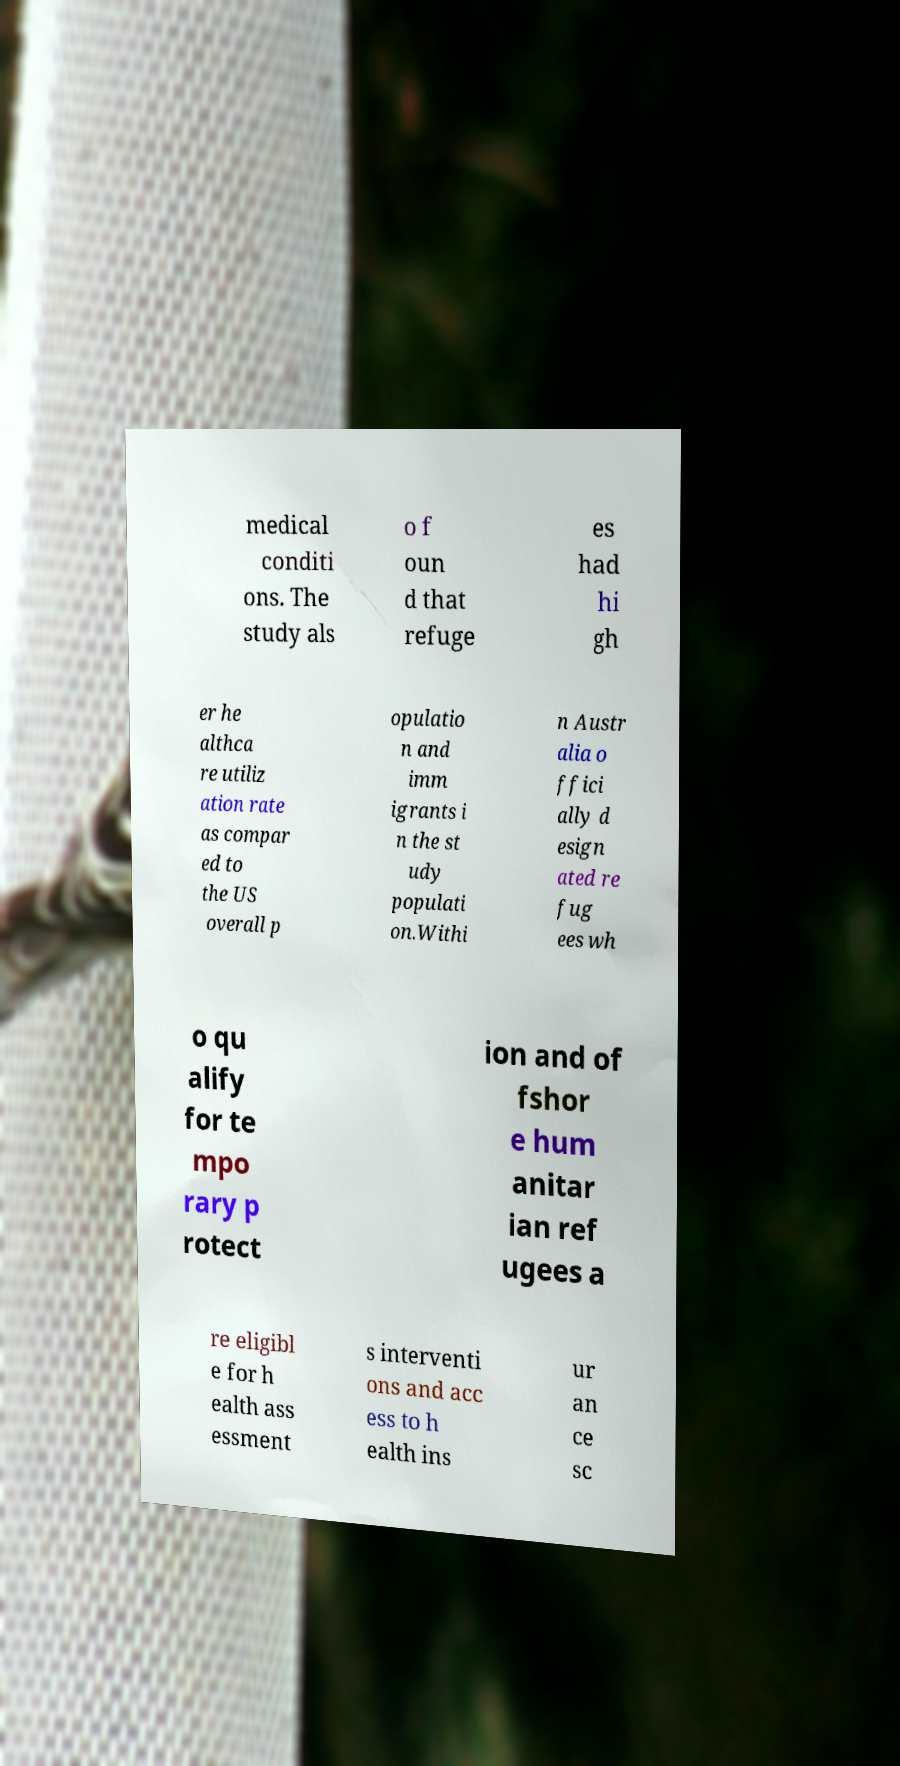Please identify and transcribe the text found in this image. medical conditi ons. The study als o f oun d that refuge es had hi gh er he althca re utiliz ation rate as compar ed to the US overall p opulatio n and imm igrants i n the st udy populati on.Withi n Austr alia o ffici ally d esign ated re fug ees wh o qu alify for te mpo rary p rotect ion and of fshor e hum anitar ian ref ugees a re eligibl e for h ealth ass essment s interventi ons and acc ess to h ealth ins ur an ce sc 